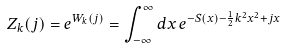<formula> <loc_0><loc_0><loc_500><loc_500>Z _ { k } ( j ) = e ^ { W _ { k } ( j ) } = \int _ { - \infty } ^ { \infty } d x \, e ^ { - S ( x ) - \frac { 1 } { 2 } k ^ { 2 } x ^ { 2 } + j x }</formula> 